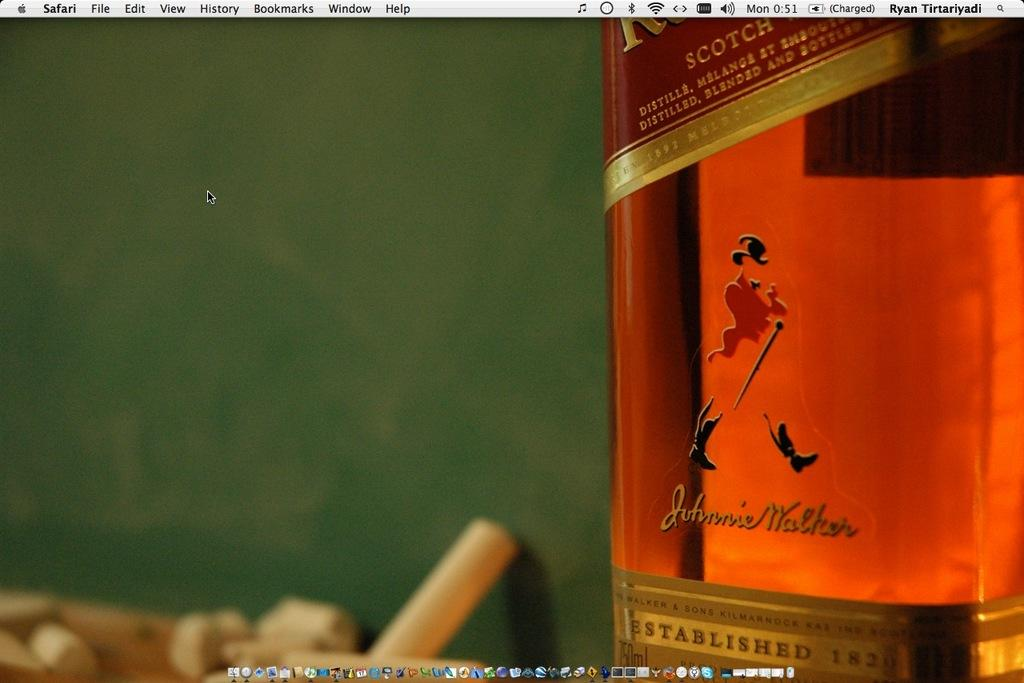<image>
Share a concise interpretation of the image provided. A bottle of Johnnie Walker Scotch sitting in front of a chalkboard 